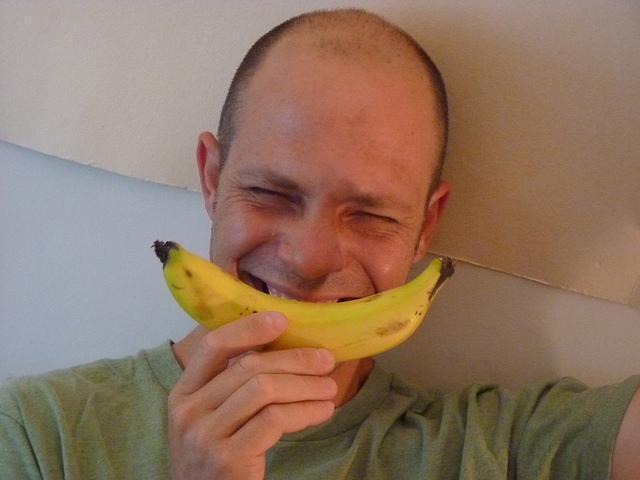How many black cars are in the picture?
Give a very brief answer. 0. 